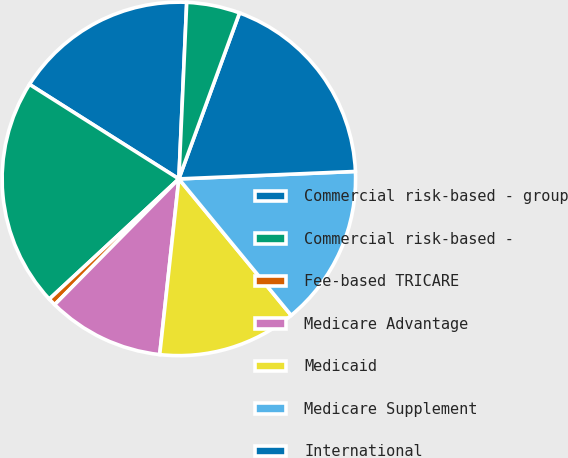<chart> <loc_0><loc_0><loc_500><loc_500><pie_chart><fcel>Commercial risk-based - group<fcel>Commercial risk-based -<fcel>Fee-based TRICARE<fcel>Medicare Advantage<fcel>Medicaid<fcel>Medicare Supplement<fcel>International<fcel>Medicare Part D stand-alone<nl><fcel>16.73%<fcel>20.88%<fcel>0.7%<fcel>10.67%<fcel>12.69%<fcel>14.71%<fcel>18.75%<fcel>4.87%<nl></chart> 